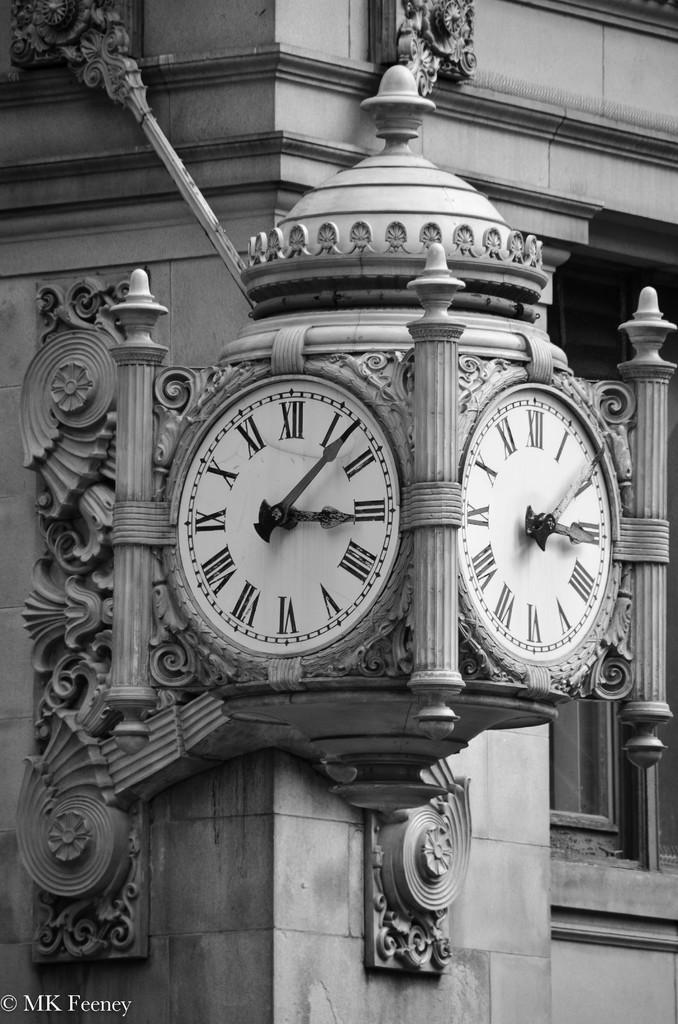<image>
Summarize the visual content of the image. Old antique clock with the hands on number 3 and 1. 